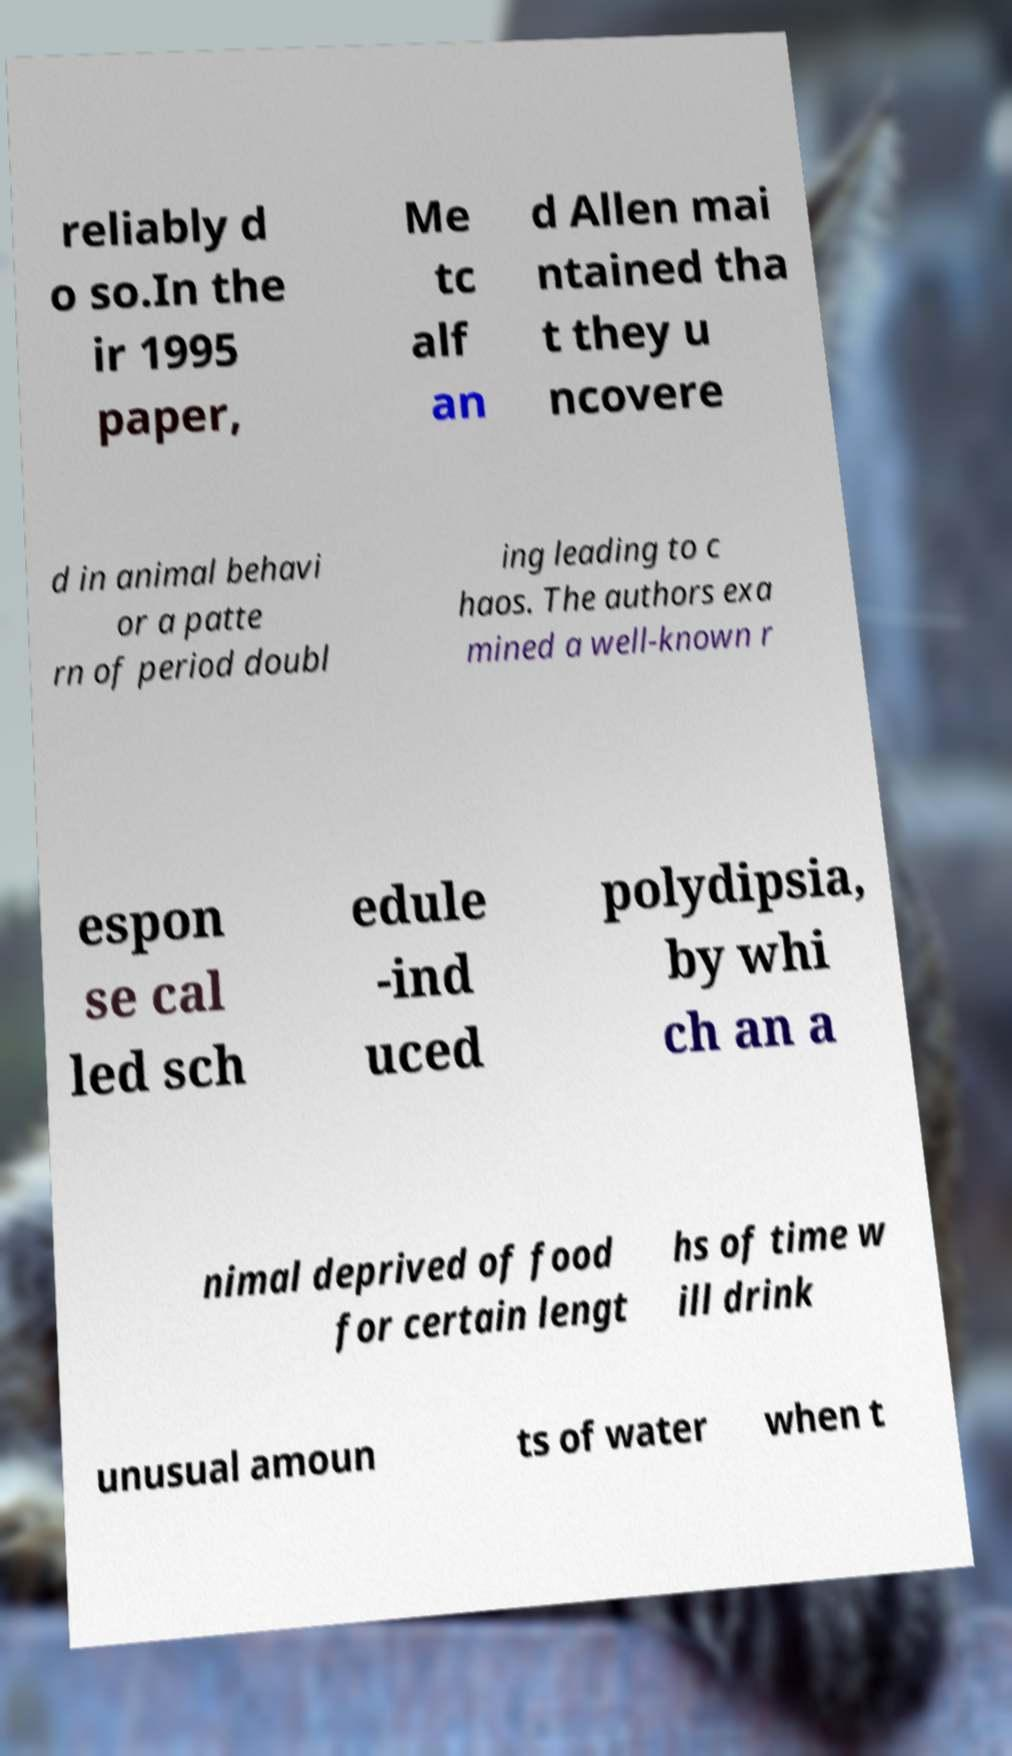What messages or text are displayed in this image? I need them in a readable, typed format. reliably d o so.In the ir 1995 paper, Me tc alf an d Allen mai ntained tha t they u ncovere d in animal behavi or a patte rn of period doubl ing leading to c haos. The authors exa mined a well-known r espon se cal led sch edule -ind uced polydipsia, by whi ch an a nimal deprived of food for certain lengt hs of time w ill drink unusual amoun ts of water when t 